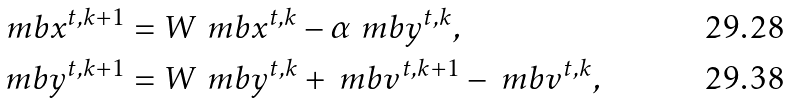<formula> <loc_0><loc_0><loc_500><loc_500>\ m b { x } ^ { t , k + 1 } & = W \ m b { x } ^ { t , k } - \alpha \ m b { y } ^ { t , k } , \\ \ m b { y } ^ { t , k + 1 } & = W \ m b { y } ^ { t , k } + \ m b { v } ^ { t , k + 1 } - \ m b { v } ^ { t , k } ,</formula> 